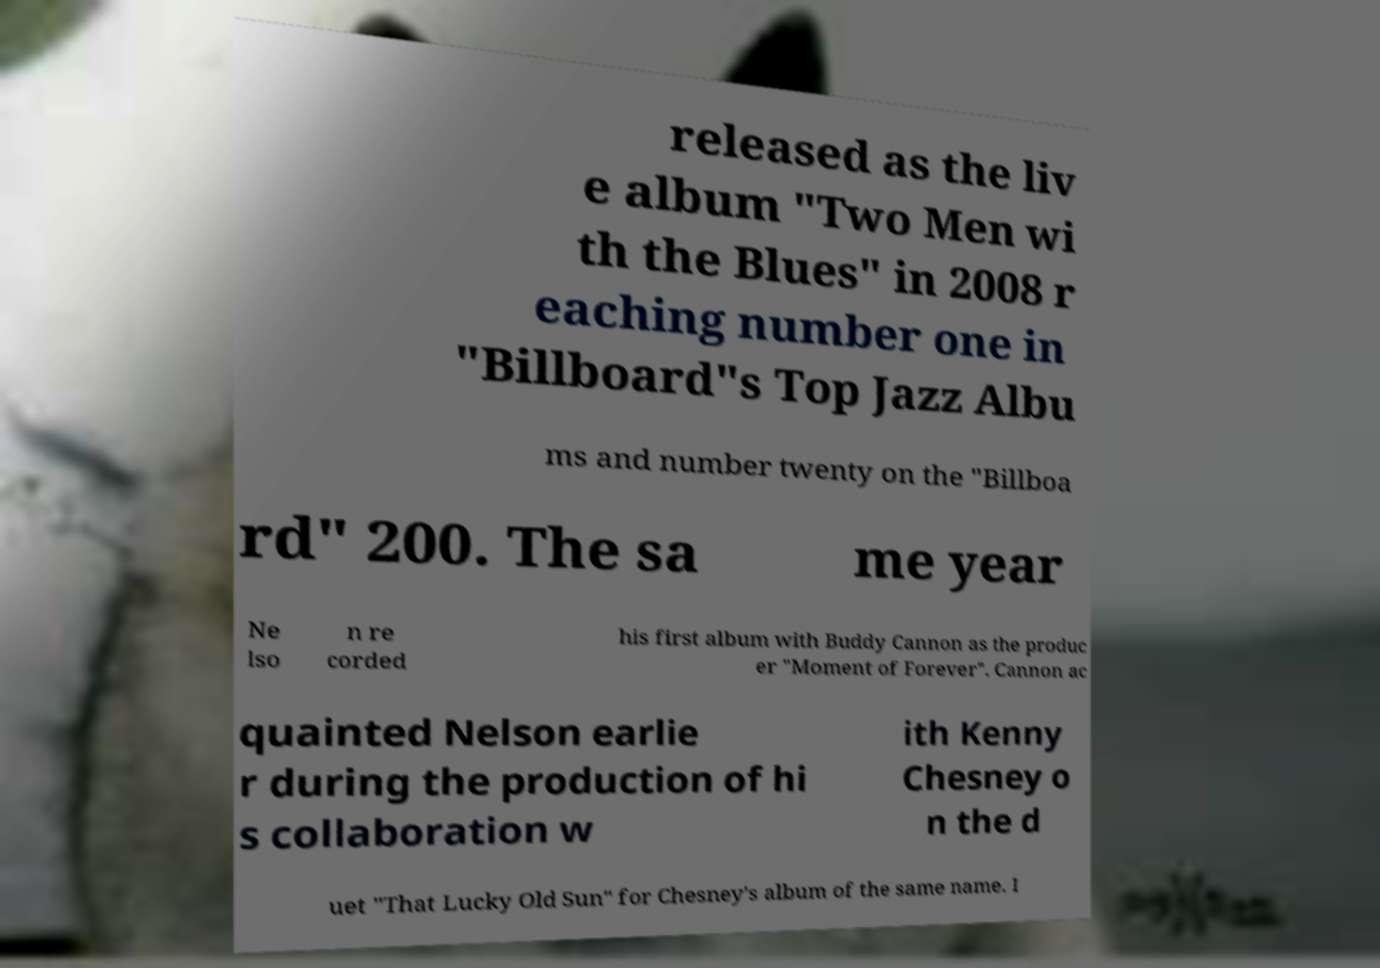What messages or text are displayed in this image? I need them in a readable, typed format. released as the liv e album "Two Men wi th the Blues" in 2008 r eaching number one in "Billboard"s Top Jazz Albu ms and number twenty on the "Billboa rd" 200. The sa me year Ne lso n re corded his first album with Buddy Cannon as the produc er "Moment of Forever". Cannon ac quainted Nelson earlie r during the production of hi s collaboration w ith Kenny Chesney o n the d uet "That Lucky Old Sun" for Chesney's album of the same name. I 